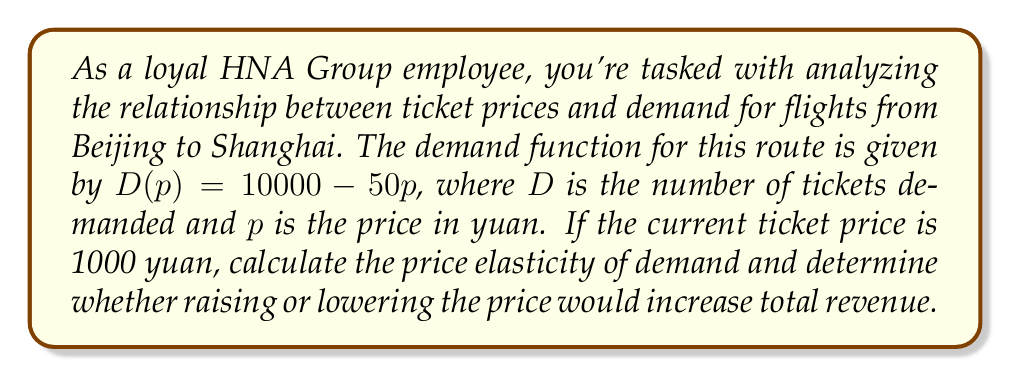Can you answer this question? To solve this problem, we'll follow these steps:

1. Calculate the price elasticity of demand
2. Interpret the elasticity
3. Determine the effect on total revenue

Step 1: Calculate the price elasticity of demand

The formula for price elasticity of demand is:

$$ E_d = \frac{\% \text{ change in quantity demanded}}{\% \text{ change in price}} = \frac{dQ/Q}{dP/P} $$

For a linear demand function $D(p) = a - bp$, the elasticity at any point is:

$$ E_d = -b \cdot \frac{p}{Q} $$

In our case, $b = 50$, $p = 1000$, and $Q = D(1000) = 10000 - 50(1000) = 5000$

Substituting these values:

$$ E_d = -50 \cdot \frac{1000}{5000} = -10 $$

Step 2: Interpret the elasticity

The absolute value of elasticity is 10, which is greater than 1. This means demand is elastic at the current price.

Step 3: Determine the effect on total revenue

When demand is elastic (|Ed| > 1):
- Lowering the price will increase total revenue
- Raising the price will decrease total revenue

This is because the percentage change in quantity demanded is greater than the percentage change in price, so the effect on quantity outweighs the effect on price.
Answer: The price elasticity of demand at the current price is -10. Since demand is elastic, lowering the ticket price would increase total revenue for HNA Group on the Beijing to Shanghai route. 